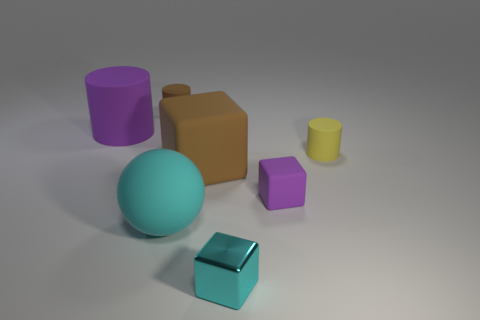What is the size of the rubber object that is the same color as the large cylinder?
Offer a very short reply. Small. Are there any other things that are the same size as the cyan shiny cube?
Offer a very short reply. Yes. Do the matte thing that is to the left of the brown cylinder and the cyan object to the left of the small cyan object have the same size?
Give a very brief answer. Yes. There is a purple object right of the cyan block; what is its size?
Your answer should be very brief. Small. There is another big thing that is the same color as the metal object; what is it made of?
Your answer should be compact. Rubber. What is the color of the sphere that is the same size as the purple rubber cylinder?
Your response must be concise. Cyan. Does the brown matte cube have the same size as the yellow cylinder?
Offer a terse response. No. There is a thing that is both on the right side of the shiny block and in front of the yellow object; how big is it?
Your response must be concise. Small. What number of shiny things are big red balls or cubes?
Give a very brief answer. 1. Is the number of big brown rubber things to the left of the tiny brown matte object greater than the number of big gray rubber blocks?
Your answer should be very brief. No. 